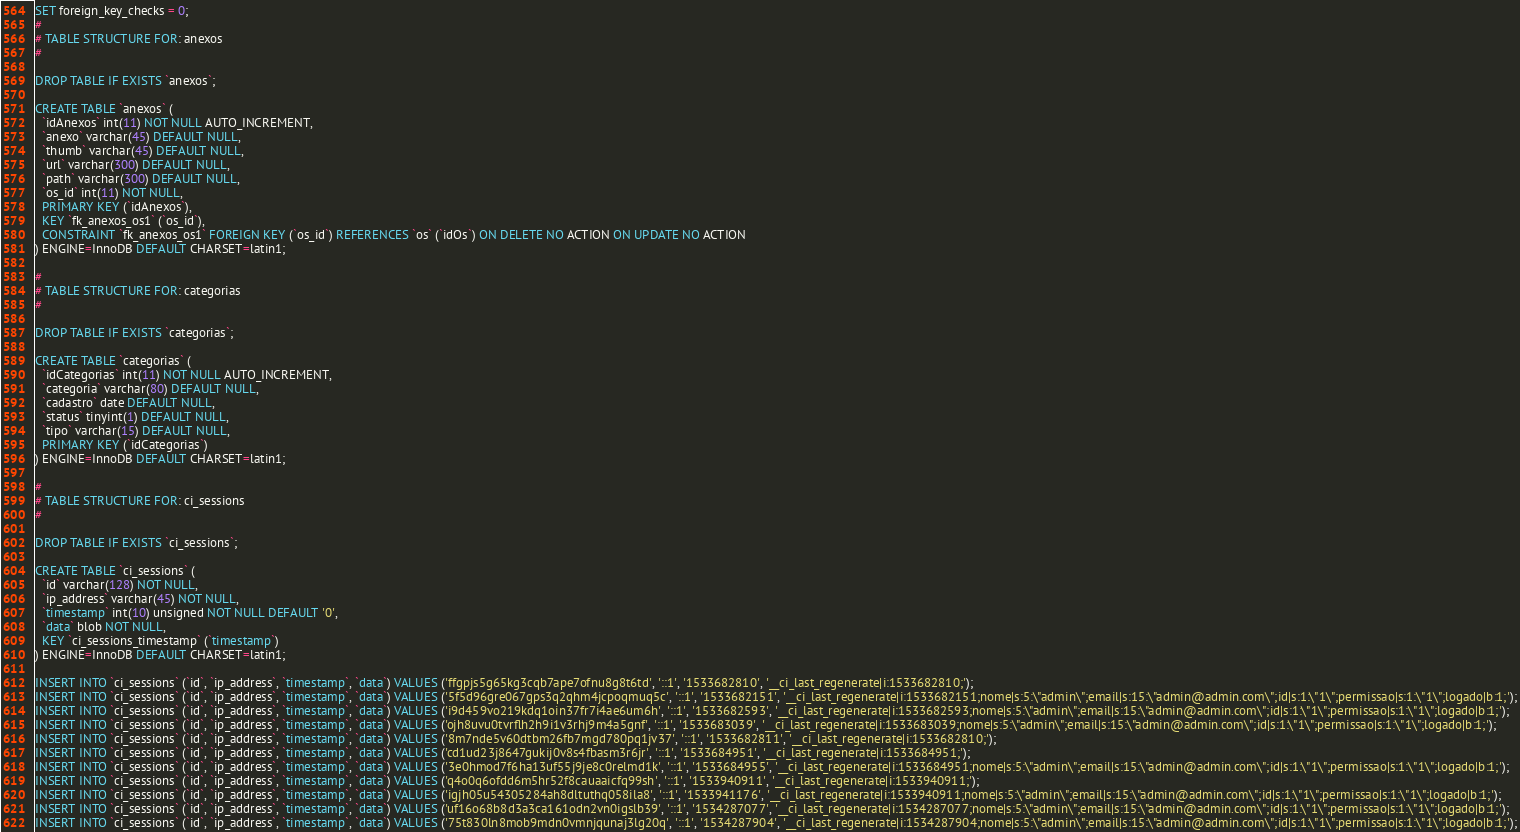Convert code to text. <code><loc_0><loc_0><loc_500><loc_500><_SQL_>SET foreign_key_checks = 0;
#
# TABLE STRUCTURE FOR: anexos
#

DROP TABLE IF EXISTS `anexos`;

CREATE TABLE `anexos` (
  `idAnexos` int(11) NOT NULL AUTO_INCREMENT,
  `anexo` varchar(45) DEFAULT NULL,
  `thumb` varchar(45) DEFAULT NULL,
  `url` varchar(300) DEFAULT NULL,
  `path` varchar(300) DEFAULT NULL,
  `os_id` int(11) NOT NULL,
  PRIMARY KEY (`idAnexos`),
  KEY `fk_anexos_os1` (`os_id`),
  CONSTRAINT `fk_anexos_os1` FOREIGN KEY (`os_id`) REFERENCES `os` (`idOs`) ON DELETE NO ACTION ON UPDATE NO ACTION
) ENGINE=InnoDB DEFAULT CHARSET=latin1;

#
# TABLE STRUCTURE FOR: categorias
#

DROP TABLE IF EXISTS `categorias`;

CREATE TABLE `categorias` (
  `idCategorias` int(11) NOT NULL AUTO_INCREMENT,
  `categoria` varchar(80) DEFAULT NULL,
  `cadastro` date DEFAULT NULL,
  `status` tinyint(1) DEFAULT NULL,
  `tipo` varchar(15) DEFAULT NULL,
  PRIMARY KEY (`idCategorias`)
) ENGINE=InnoDB DEFAULT CHARSET=latin1;

#
# TABLE STRUCTURE FOR: ci_sessions
#

DROP TABLE IF EXISTS `ci_sessions`;

CREATE TABLE `ci_sessions` (
  `id` varchar(128) NOT NULL,
  `ip_address` varchar(45) NOT NULL,
  `timestamp` int(10) unsigned NOT NULL DEFAULT '0',
  `data` blob NOT NULL,
  KEY `ci_sessions_timestamp` (`timestamp`)
) ENGINE=InnoDB DEFAULT CHARSET=latin1;

INSERT INTO `ci_sessions` (`id`, `ip_address`, `timestamp`, `data`) VALUES ('ffgpjs5g65kg3cqb7ape7ofnu8g8t6td', '::1', '1533682810', '__ci_last_regenerate|i:1533682810;');
INSERT INTO `ci_sessions` (`id`, `ip_address`, `timestamp`, `data`) VALUES ('5f5d96gre067gps3q2qhm4jcpoqmuq5c', '::1', '1533682151', '__ci_last_regenerate|i:1533682151;nome|s:5:\"admin\";email|s:15:\"admin@admin.com\";id|s:1:\"1\";permissao|s:1:\"1\";logado|b:1;');
INSERT INTO `ci_sessions` (`id`, `ip_address`, `timestamp`, `data`) VALUES ('i9d459vo219kdq1oin37fr7i4ae6um6h', '::1', '1533682593', '__ci_last_regenerate|i:1533682593;nome|s:5:\"admin\";email|s:15:\"admin@admin.com\";id|s:1:\"1\";permissao|s:1:\"1\";logado|b:1;');
INSERT INTO `ci_sessions` (`id`, `ip_address`, `timestamp`, `data`) VALUES ('ojh8uvu0tvrflh2h9i1v3rhj9m4a5gnf', '::1', '1533683039', '__ci_last_regenerate|i:1533683039;nome|s:5:\"admin\";email|s:15:\"admin@admin.com\";id|s:1:\"1\";permissao|s:1:\"1\";logado|b:1;');
INSERT INTO `ci_sessions` (`id`, `ip_address`, `timestamp`, `data`) VALUES ('8m7nde5v60dtbm26fb7mgd780pq1jv37', '::1', '1533682811', '__ci_last_regenerate|i:1533682810;');
INSERT INTO `ci_sessions` (`id`, `ip_address`, `timestamp`, `data`) VALUES ('cd1ud23j8647gukij0v8s4fbasm3r6jr', '::1', '1533684951', '__ci_last_regenerate|i:1533684951;');
INSERT INTO `ci_sessions` (`id`, `ip_address`, `timestamp`, `data`) VALUES ('3e0hmod7f6ha13uf55j9je8c0relmd1k', '::1', '1533684955', '__ci_last_regenerate|i:1533684951;nome|s:5:\"admin\";email|s:15:\"admin@admin.com\";id|s:1:\"1\";permissao|s:1:\"1\";logado|b:1;');
INSERT INTO `ci_sessions` (`id`, `ip_address`, `timestamp`, `data`) VALUES ('q4o0q6ofdd6m5hr52f8cauaaicfq99sh', '::1', '1533940911', '__ci_last_regenerate|i:1533940911;');
INSERT INTO `ci_sessions` (`id`, `ip_address`, `timestamp`, `data`) VALUES ('igjh05u54305284ah8dltuthq058ila8', '::1', '1533941176', '__ci_last_regenerate|i:1533940911;nome|s:5:\"admin\";email|s:15:\"admin@admin.com\";id|s:1:\"1\";permissao|s:1:\"1\";logado|b:1;');
INSERT INTO `ci_sessions` (`id`, `ip_address`, `timestamp`, `data`) VALUES ('uf16o68b8d3a3ca161odn2vn0igslb39', '::1', '1534287077', '__ci_last_regenerate|i:1534287077;nome|s:5:\"admin\";email|s:15:\"admin@admin.com\";id|s:1:\"1\";permissao|s:1:\"1\";logado|b:1;');
INSERT INTO `ci_sessions` (`id`, `ip_address`, `timestamp`, `data`) VALUES ('75t830ln8mob9mdn0vmnjqunaj3lg20q', '::1', '1534287904', '__ci_last_regenerate|i:1534287904;nome|s:5:\"admin\";email|s:15:\"admin@admin.com\";id|s:1:\"1\";permissao|s:1:\"1\";logado|b:1;');</code> 